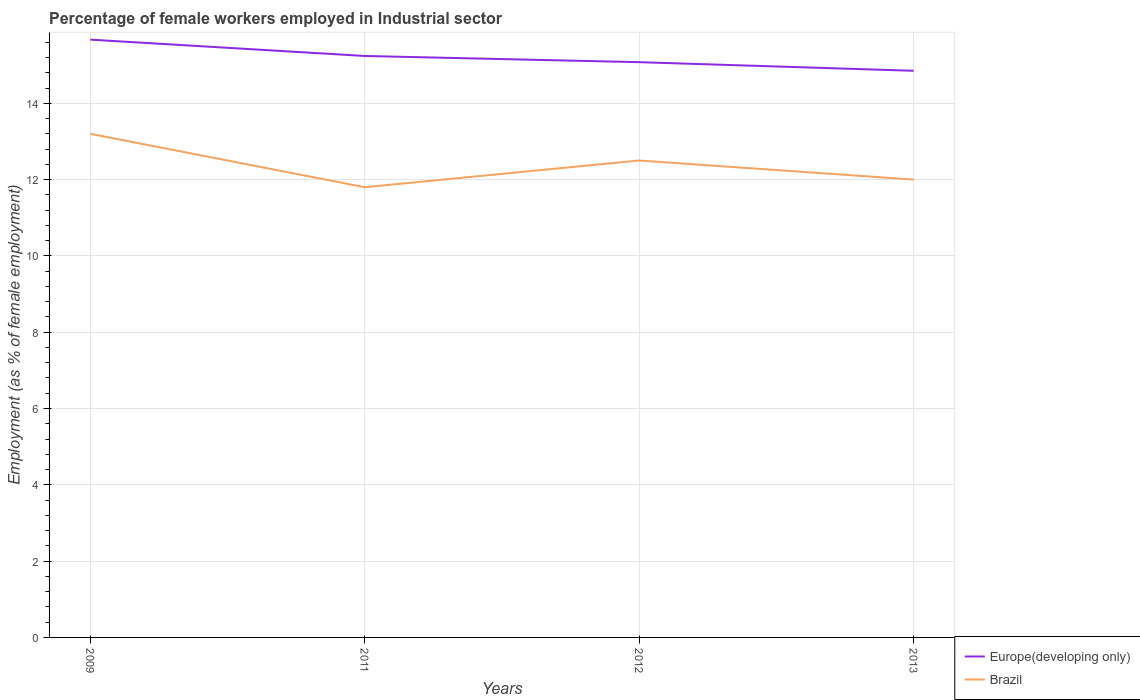Across all years, what is the maximum percentage of females employed in Industrial sector in Brazil?
Keep it short and to the point. 11.8. In which year was the percentage of females employed in Industrial sector in Brazil maximum?
Provide a short and direct response. 2011. What is the total percentage of females employed in Industrial sector in Europe(developing only) in the graph?
Your response must be concise. 0.82. What is the difference between the highest and the second highest percentage of females employed in Industrial sector in Brazil?
Offer a very short reply. 1.4. How many years are there in the graph?
Your answer should be compact. 4. Are the values on the major ticks of Y-axis written in scientific E-notation?
Provide a short and direct response. No. Does the graph contain any zero values?
Your answer should be very brief. No. Does the graph contain grids?
Offer a terse response. Yes. Where does the legend appear in the graph?
Offer a very short reply. Bottom right. What is the title of the graph?
Give a very brief answer. Percentage of female workers employed in Industrial sector. What is the label or title of the Y-axis?
Offer a very short reply. Employment (as % of female employment). What is the Employment (as % of female employment) of Europe(developing only) in 2009?
Ensure brevity in your answer.  15.67. What is the Employment (as % of female employment) in Brazil in 2009?
Ensure brevity in your answer.  13.2. What is the Employment (as % of female employment) in Europe(developing only) in 2011?
Give a very brief answer. 15.24. What is the Employment (as % of female employment) in Brazil in 2011?
Provide a succinct answer. 11.8. What is the Employment (as % of female employment) in Europe(developing only) in 2012?
Your answer should be very brief. 15.08. What is the Employment (as % of female employment) in Europe(developing only) in 2013?
Offer a very short reply. 14.85. What is the Employment (as % of female employment) in Brazil in 2013?
Your answer should be compact. 12. Across all years, what is the maximum Employment (as % of female employment) of Europe(developing only)?
Your answer should be very brief. 15.67. Across all years, what is the maximum Employment (as % of female employment) of Brazil?
Provide a short and direct response. 13.2. Across all years, what is the minimum Employment (as % of female employment) of Europe(developing only)?
Make the answer very short. 14.85. Across all years, what is the minimum Employment (as % of female employment) in Brazil?
Your response must be concise. 11.8. What is the total Employment (as % of female employment) of Europe(developing only) in the graph?
Offer a very short reply. 60.84. What is the total Employment (as % of female employment) in Brazil in the graph?
Ensure brevity in your answer.  49.5. What is the difference between the Employment (as % of female employment) in Europe(developing only) in 2009 and that in 2011?
Your answer should be compact. 0.43. What is the difference between the Employment (as % of female employment) of Europe(developing only) in 2009 and that in 2012?
Your answer should be compact. 0.59. What is the difference between the Employment (as % of female employment) in Brazil in 2009 and that in 2012?
Provide a short and direct response. 0.7. What is the difference between the Employment (as % of female employment) of Europe(developing only) in 2009 and that in 2013?
Ensure brevity in your answer.  0.82. What is the difference between the Employment (as % of female employment) of Europe(developing only) in 2011 and that in 2012?
Offer a very short reply. 0.16. What is the difference between the Employment (as % of female employment) of Europe(developing only) in 2011 and that in 2013?
Offer a terse response. 0.39. What is the difference between the Employment (as % of female employment) of Brazil in 2011 and that in 2013?
Make the answer very short. -0.2. What is the difference between the Employment (as % of female employment) of Europe(developing only) in 2012 and that in 2013?
Provide a succinct answer. 0.23. What is the difference between the Employment (as % of female employment) of Europe(developing only) in 2009 and the Employment (as % of female employment) of Brazil in 2011?
Provide a short and direct response. 3.87. What is the difference between the Employment (as % of female employment) of Europe(developing only) in 2009 and the Employment (as % of female employment) of Brazil in 2012?
Your answer should be compact. 3.17. What is the difference between the Employment (as % of female employment) of Europe(developing only) in 2009 and the Employment (as % of female employment) of Brazil in 2013?
Offer a terse response. 3.67. What is the difference between the Employment (as % of female employment) in Europe(developing only) in 2011 and the Employment (as % of female employment) in Brazil in 2012?
Give a very brief answer. 2.74. What is the difference between the Employment (as % of female employment) in Europe(developing only) in 2011 and the Employment (as % of female employment) in Brazil in 2013?
Your response must be concise. 3.24. What is the difference between the Employment (as % of female employment) of Europe(developing only) in 2012 and the Employment (as % of female employment) of Brazil in 2013?
Offer a terse response. 3.08. What is the average Employment (as % of female employment) of Europe(developing only) per year?
Ensure brevity in your answer.  15.21. What is the average Employment (as % of female employment) in Brazil per year?
Provide a short and direct response. 12.38. In the year 2009, what is the difference between the Employment (as % of female employment) in Europe(developing only) and Employment (as % of female employment) in Brazil?
Offer a very short reply. 2.47. In the year 2011, what is the difference between the Employment (as % of female employment) in Europe(developing only) and Employment (as % of female employment) in Brazil?
Give a very brief answer. 3.44. In the year 2012, what is the difference between the Employment (as % of female employment) of Europe(developing only) and Employment (as % of female employment) of Brazil?
Provide a short and direct response. 2.58. In the year 2013, what is the difference between the Employment (as % of female employment) in Europe(developing only) and Employment (as % of female employment) in Brazil?
Your response must be concise. 2.85. What is the ratio of the Employment (as % of female employment) in Europe(developing only) in 2009 to that in 2011?
Ensure brevity in your answer.  1.03. What is the ratio of the Employment (as % of female employment) in Brazil in 2009 to that in 2011?
Provide a succinct answer. 1.12. What is the ratio of the Employment (as % of female employment) in Europe(developing only) in 2009 to that in 2012?
Offer a terse response. 1.04. What is the ratio of the Employment (as % of female employment) of Brazil in 2009 to that in 2012?
Give a very brief answer. 1.06. What is the ratio of the Employment (as % of female employment) in Europe(developing only) in 2009 to that in 2013?
Offer a very short reply. 1.05. What is the ratio of the Employment (as % of female employment) in Brazil in 2009 to that in 2013?
Offer a very short reply. 1.1. What is the ratio of the Employment (as % of female employment) in Europe(developing only) in 2011 to that in 2012?
Your answer should be compact. 1.01. What is the ratio of the Employment (as % of female employment) of Brazil in 2011 to that in 2012?
Your response must be concise. 0.94. What is the ratio of the Employment (as % of female employment) of Europe(developing only) in 2011 to that in 2013?
Provide a succinct answer. 1.03. What is the ratio of the Employment (as % of female employment) in Brazil in 2011 to that in 2013?
Ensure brevity in your answer.  0.98. What is the ratio of the Employment (as % of female employment) of Europe(developing only) in 2012 to that in 2013?
Your answer should be compact. 1.02. What is the ratio of the Employment (as % of female employment) in Brazil in 2012 to that in 2013?
Make the answer very short. 1.04. What is the difference between the highest and the second highest Employment (as % of female employment) of Europe(developing only)?
Offer a very short reply. 0.43. What is the difference between the highest and the lowest Employment (as % of female employment) in Europe(developing only)?
Keep it short and to the point. 0.82. 